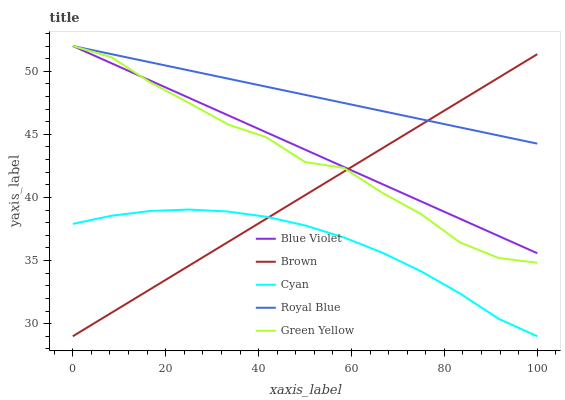Does Cyan have the minimum area under the curve?
Answer yes or no. Yes. Does Royal Blue have the maximum area under the curve?
Answer yes or no. Yes. Does Brown have the minimum area under the curve?
Answer yes or no. No. Does Brown have the maximum area under the curve?
Answer yes or no. No. Is Royal Blue the smoothest?
Answer yes or no. Yes. Is Green Yellow the roughest?
Answer yes or no. Yes. Is Brown the smoothest?
Answer yes or no. No. Is Brown the roughest?
Answer yes or no. No. Does Brown have the lowest value?
Answer yes or no. Yes. Does Green Yellow have the lowest value?
Answer yes or no. No. Does Blue Violet have the highest value?
Answer yes or no. Yes. Does Brown have the highest value?
Answer yes or no. No. Is Cyan less than Blue Violet?
Answer yes or no. Yes. Is Royal Blue greater than Cyan?
Answer yes or no. Yes. Does Green Yellow intersect Blue Violet?
Answer yes or no. Yes. Is Green Yellow less than Blue Violet?
Answer yes or no. No. Is Green Yellow greater than Blue Violet?
Answer yes or no. No. Does Cyan intersect Blue Violet?
Answer yes or no. No. 